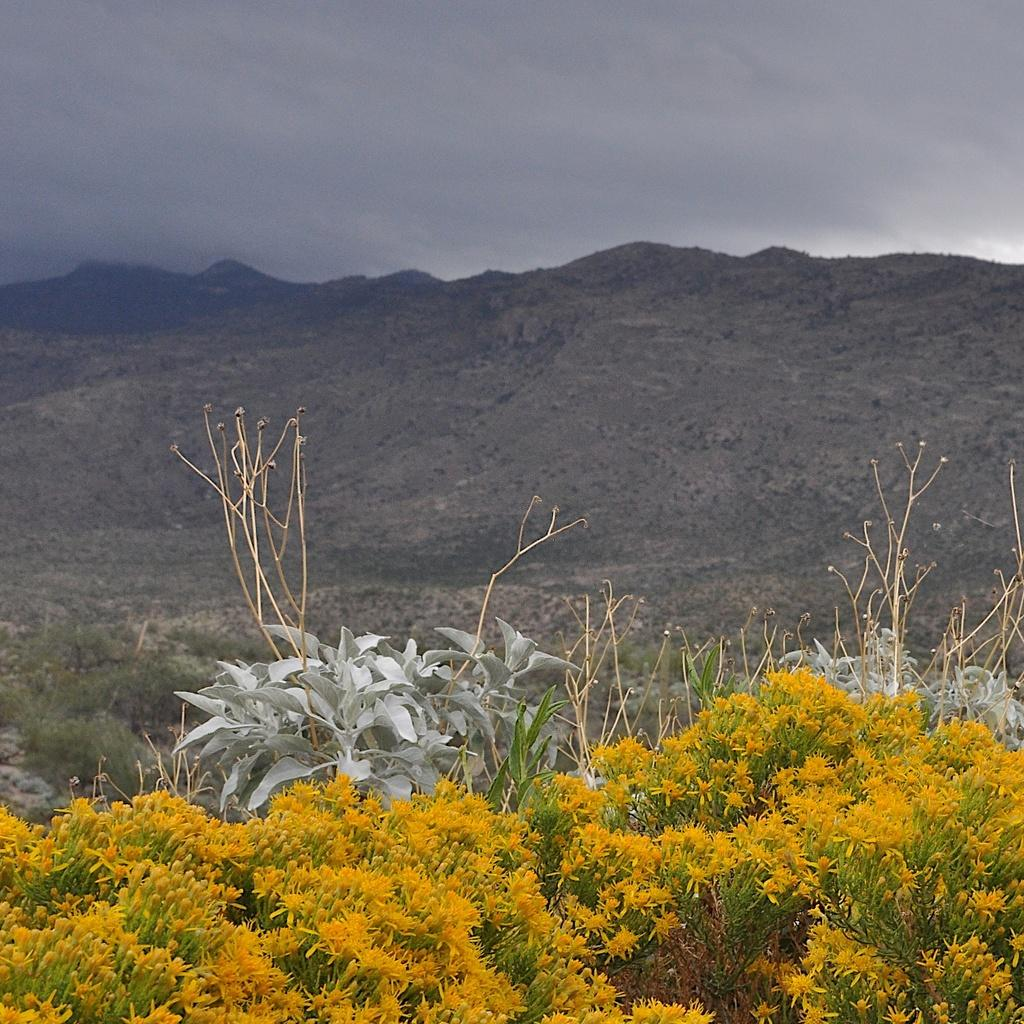What type of flowers can be seen at the bottom of the image? There are yellow color flowers at the bottom of the image. What else can be seen in the background of the image? There are plants in the background of the image. What natural feature is visible in the image? Hills are visible in the image. What is visible in the sky in the image? The sky is visible in the image, and clouds are present. What type of game is being played on the hills in the image? There is no game being played in the image; it only shows flowers, plants, hills, and the sky with clouds. 